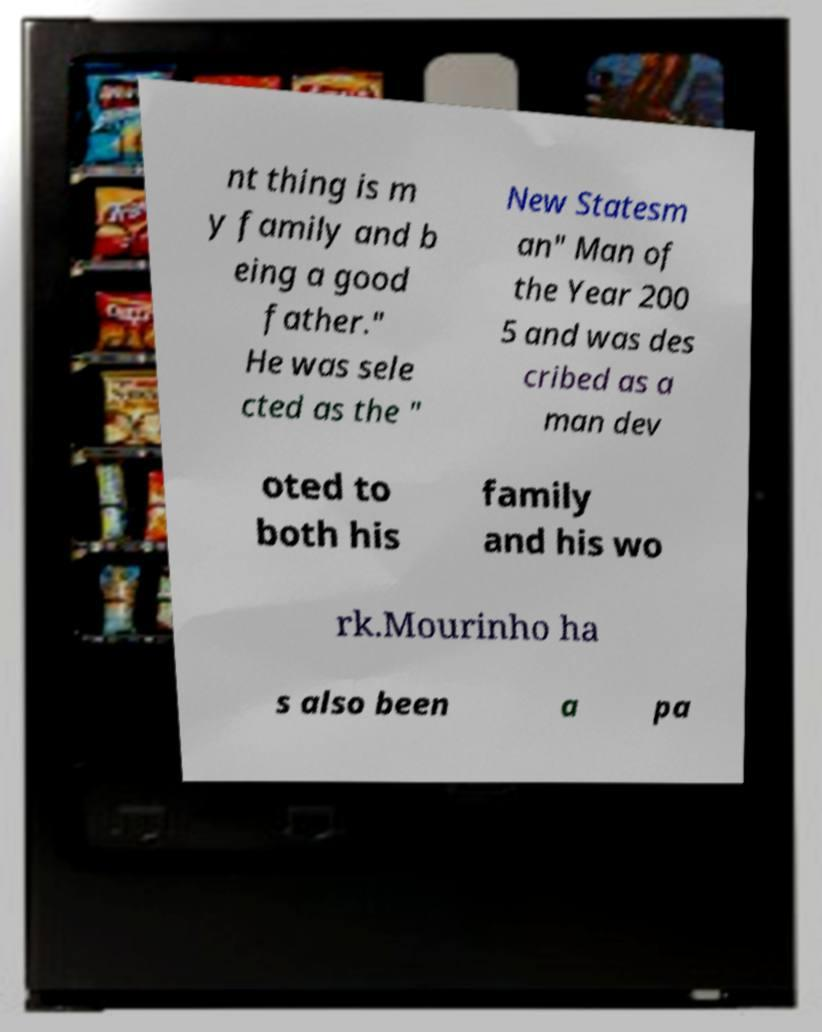What is unique about the setting of the image? The image presents an intriguing juxtaposition of a household TV displaying what seems to be a casual background with snacks, overlaid by a seemingly significant piece of printed text, creating a contrast between everyday life and notable achievements. Can you tell more about the significance of the snacks in the background? The snacks in the background might not hold significant symbolic value but reflect a common, relaxed domestic scene. They contrast the serious tone of the printed text, perhaps hinting at the balance between personal leisure and professional accomplishment in someone's life. 